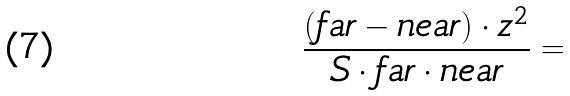<formula> <loc_0><loc_0><loc_500><loc_500>\frac { ( f a r - n e a r ) \cdot z ^ { 2 } } { S \cdot f a r \cdot n e a r } =</formula> 